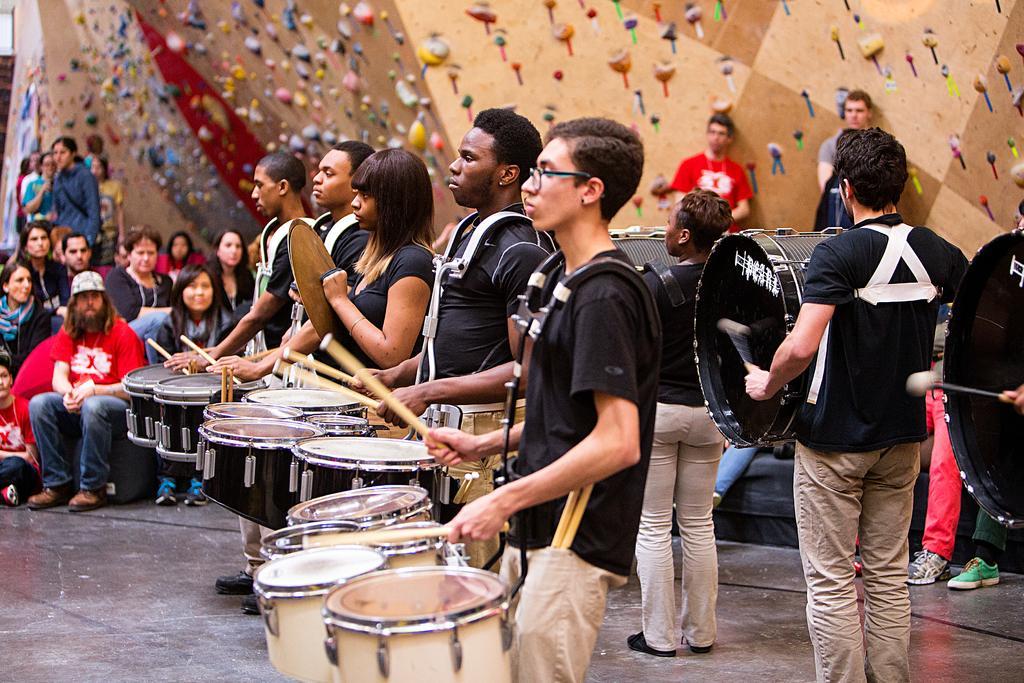Can you describe this image briefly? Here we see a group of people performing with drums and few people seated and watching them. 